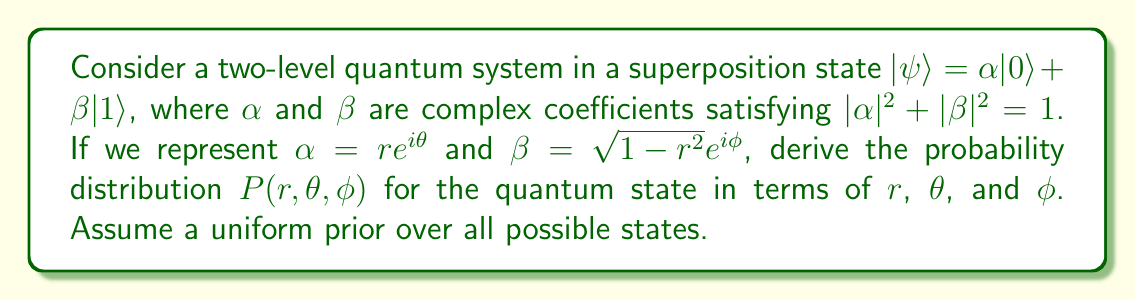Teach me how to tackle this problem. Let's approach this step-by-step:

1) First, recall that the normalization condition for quantum states requires:
   $$|\alpha|^2 + |\beta|^2 = 1$$

2) We've parametrized $\alpha$ and $\beta$ as:
   $$\alpha = re^{i\theta}$$
   $$\beta = \sqrt{1-r^2}e^{i\phi}$$

3) The volume element in the complex plane for $\alpha$ and $\beta$ is:
   $$d\alpha d\alpha^* d\beta d\beta^* = 4r(1-r^2)drd\theta d\phi$$

4) The probability distribution should be proportional to this volume element:
   $$P(r,\theta,\phi) \propto r(1-r^2)$$

5) To normalize this distribution, we need to integrate over all possible values:
   $$\int_0^1 \int_0^{2\pi} \int_0^{2\pi} Cr(1-r^2)drd\theta d\phi = 1$$
   where $C$ is the normalization constant.

6) Solving this integral:
   $$C \cdot 2\pi \cdot 2\pi \cdot \frac{1}{4} = 1$$
   $$C = \frac{1}{4\pi^2}$$

7) Therefore, the normalized probability distribution is:
   $$P(r,\theta,\phi) = \frac{1}{4\pi^2}r(1-r^2)$$

This distribution shows that states with $r$ close to $\frac{1}{\sqrt{2}}$ are more probable, which corresponds to equal superpositions of $|0\rangle$ and $|1\rangle$.
Answer: $P(r,\theta,\phi) = \frac{1}{4\pi^2}r(1-r^2)$ 